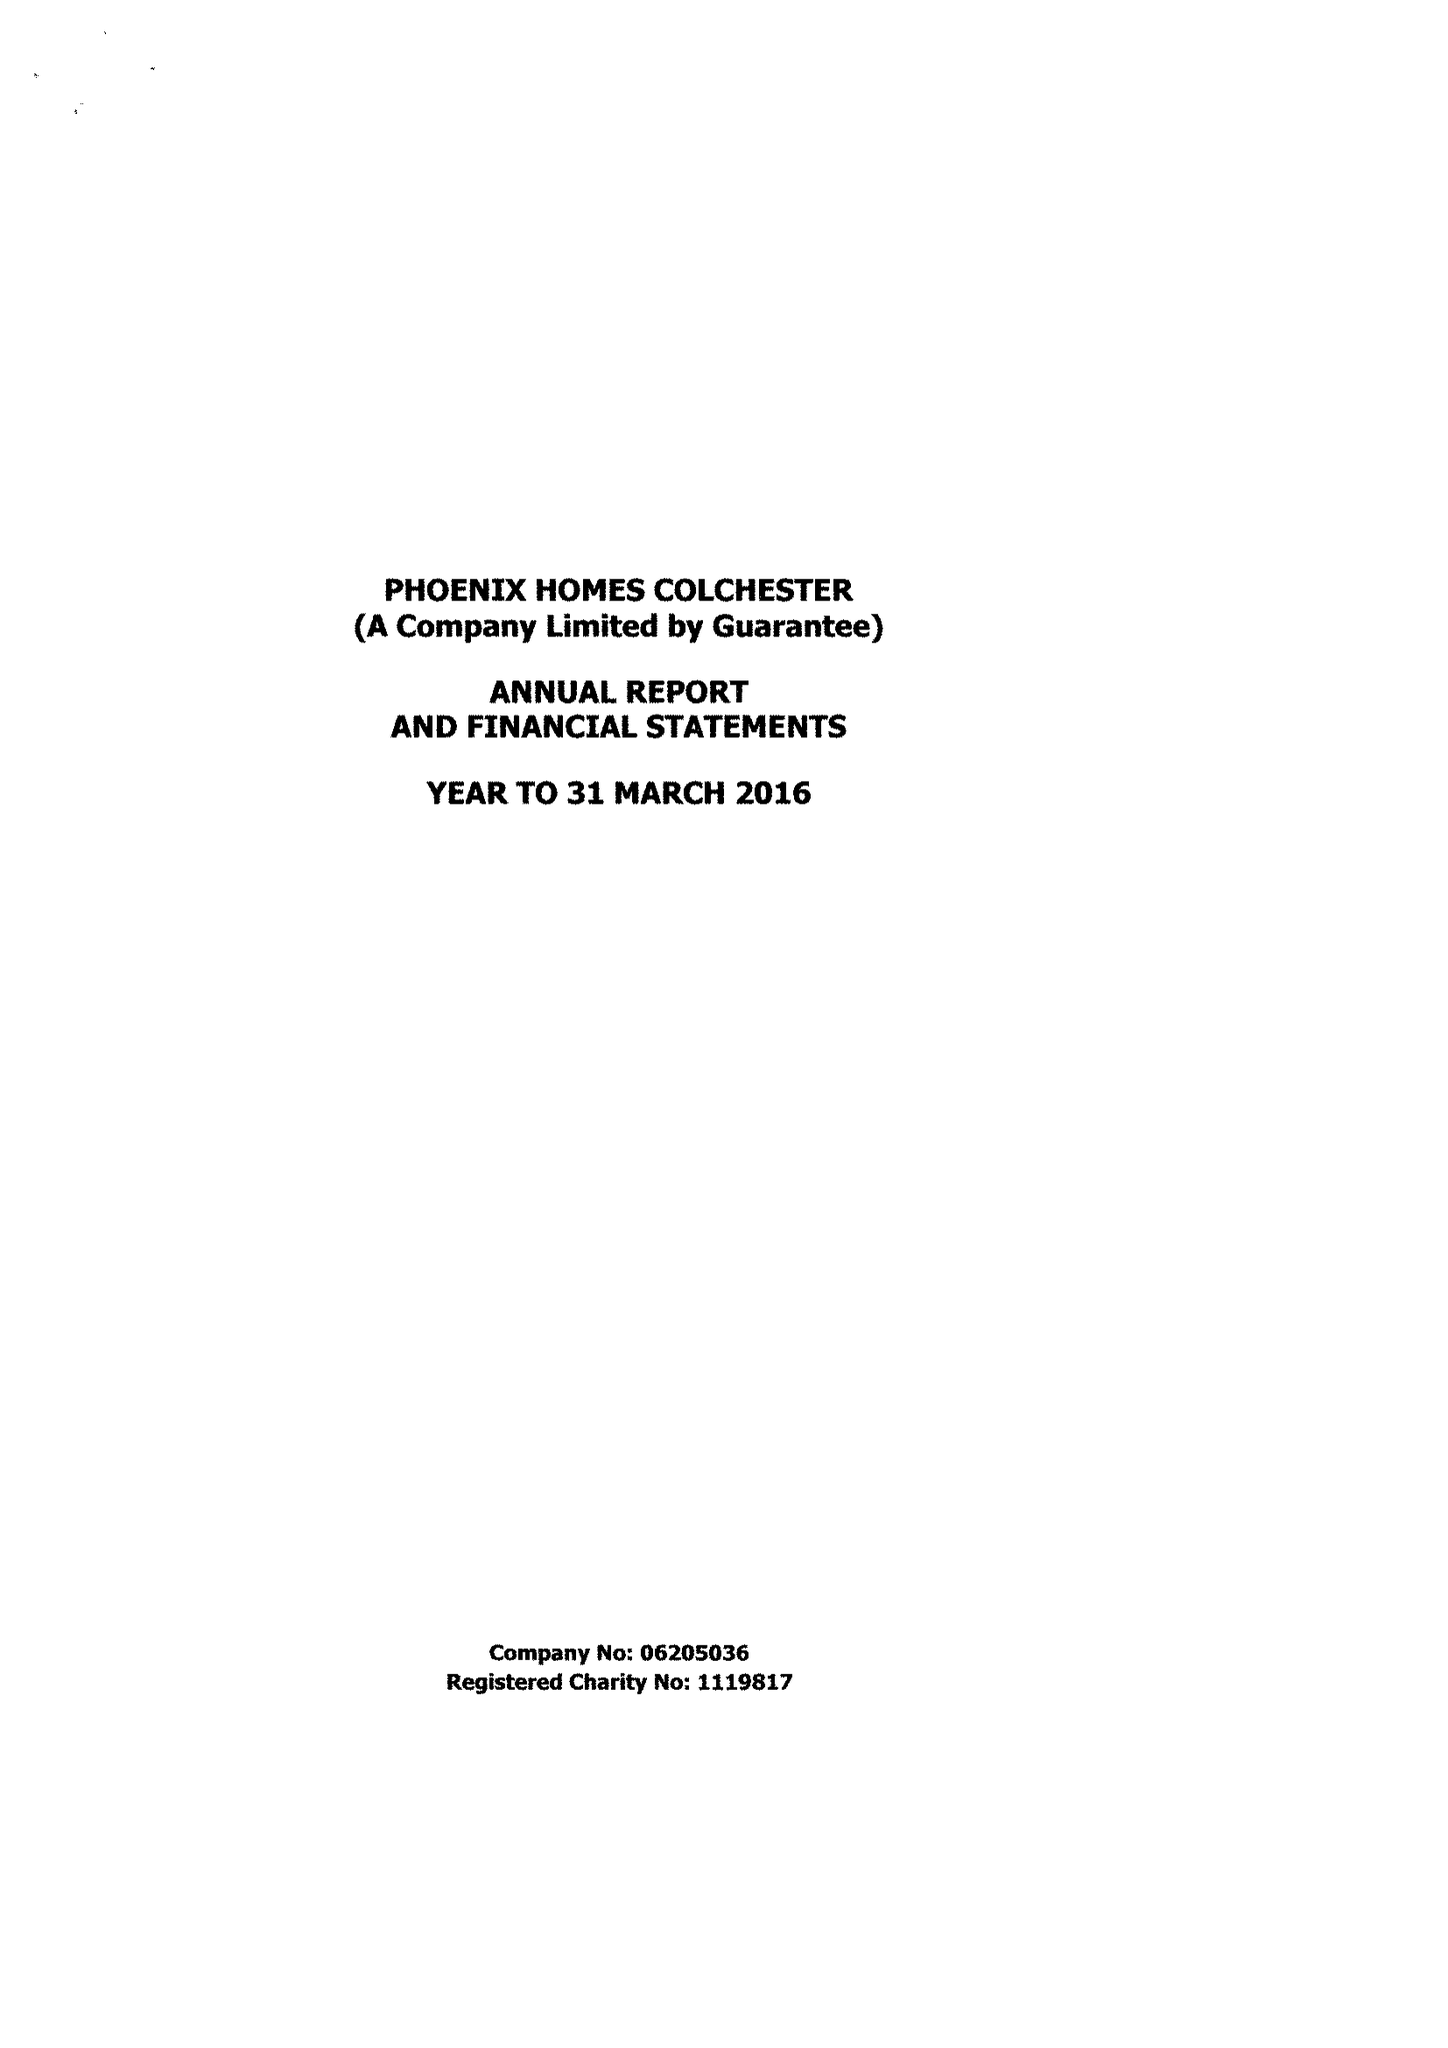What is the value for the address__street_line?
Answer the question using a single word or phrase. 147 STRAIGHT ROAD 